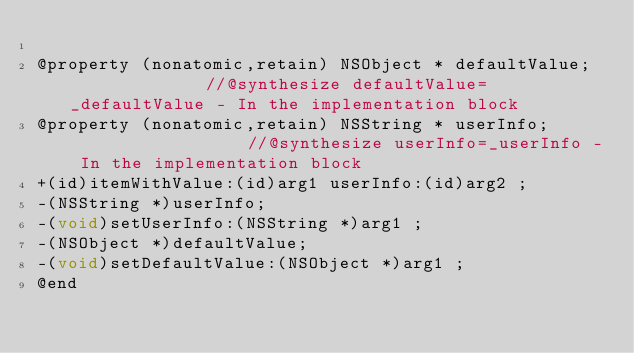<code> <loc_0><loc_0><loc_500><loc_500><_C_>
@property (nonatomic,retain) NSObject * defaultValue;              //@synthesize defaultValue=_defaultValue - In the implementation block
@property (nonatomic,retain) NSString * userInfo;                  //@synthesize userInfo=_userInfo - In the implementation block
+(id)itemWithValue:(id)arg1 userInfo:(id)arg2 ;
-(NSString *)userInfo;
-(void)setUserInfo:(NSString *)arg1 ;
-(NSObject *)defaultValue;
-(void)setDefaultValue:(NSObject *)arg1 ;
@end

</code> 